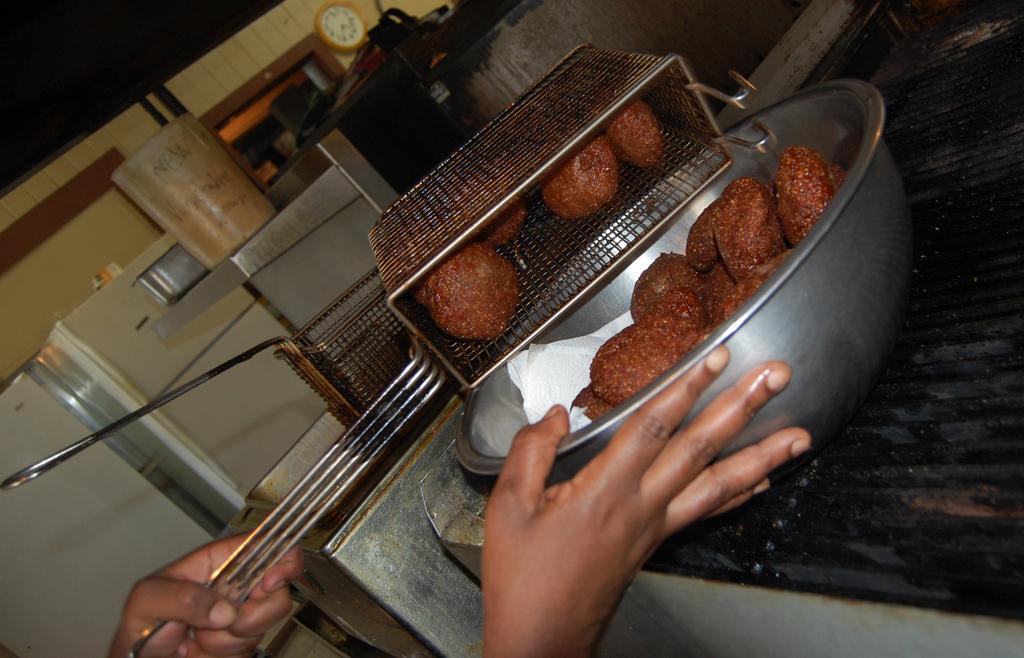Describe this image in one or two sentences. In this image there are hands one hand is holding vessel and another one is holding a bowl, in that there are food items at the bottom there a table, in the background there is a fridge, tin, clock 